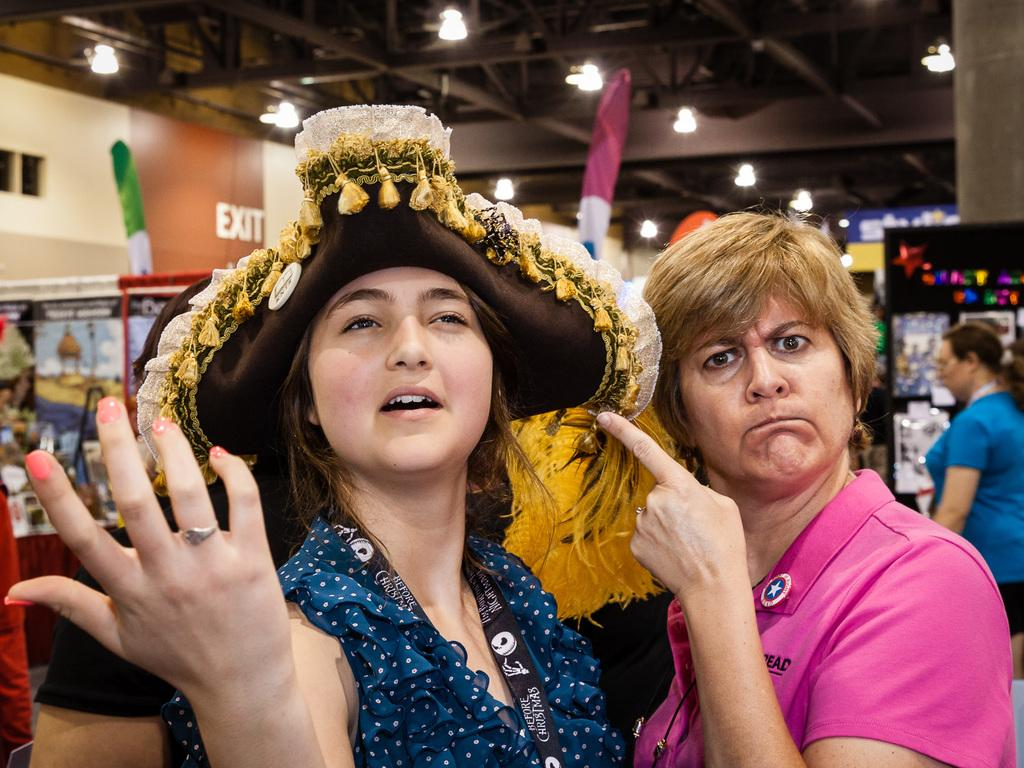How many women are present in the image? There are three women in the image. Can you describe the women in the middle of the image? There are two women in the middle of the image. What is the woman on the right side of the image wearing? The woman on the right side of the image is wearing a blue color t-shirt. What can be seen at the top of the image? There are lights visible at the top of the image. What type of location might the image depict? The image appears to depict a store. What type of honey is being sold by the women in the image? There is no honey present in the image, and the women are not selling any products. 